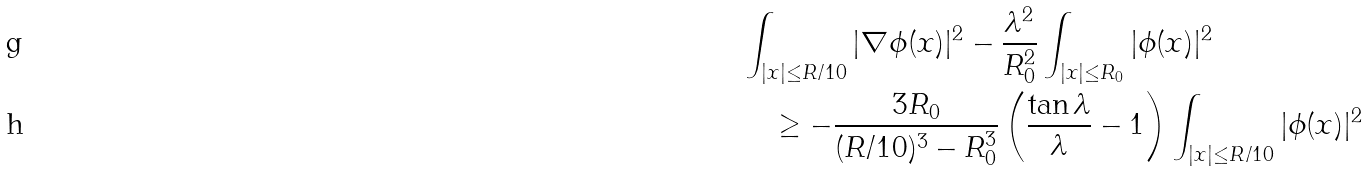Convert formula to latex. <formula><loc_0><loc_0><loc_500><loc_500>& \int _ { | x | \leq R / 1 0 } | \nabla \phi ( x ) | ^ { 2 } - \frac { \lambda ^ { 2 } } { R _ { 0 } ^ { 2 } } \int _ { | x | \leq R _ { 0 } } | \phi ( x ) | ^ { 2 } \\ & \quad \geq - \frac { 3 R _ { 0 } } { ( R / 1 0 ) ^ { 3 } - R _ { 0 } ^ { 3 } } \left ( \frac { \tan \lambda } \lambda - 1 \right ) \int _ { | x | \leq R / 1 0 } | \phi ( x ) | ^ { 2 }</formula> 